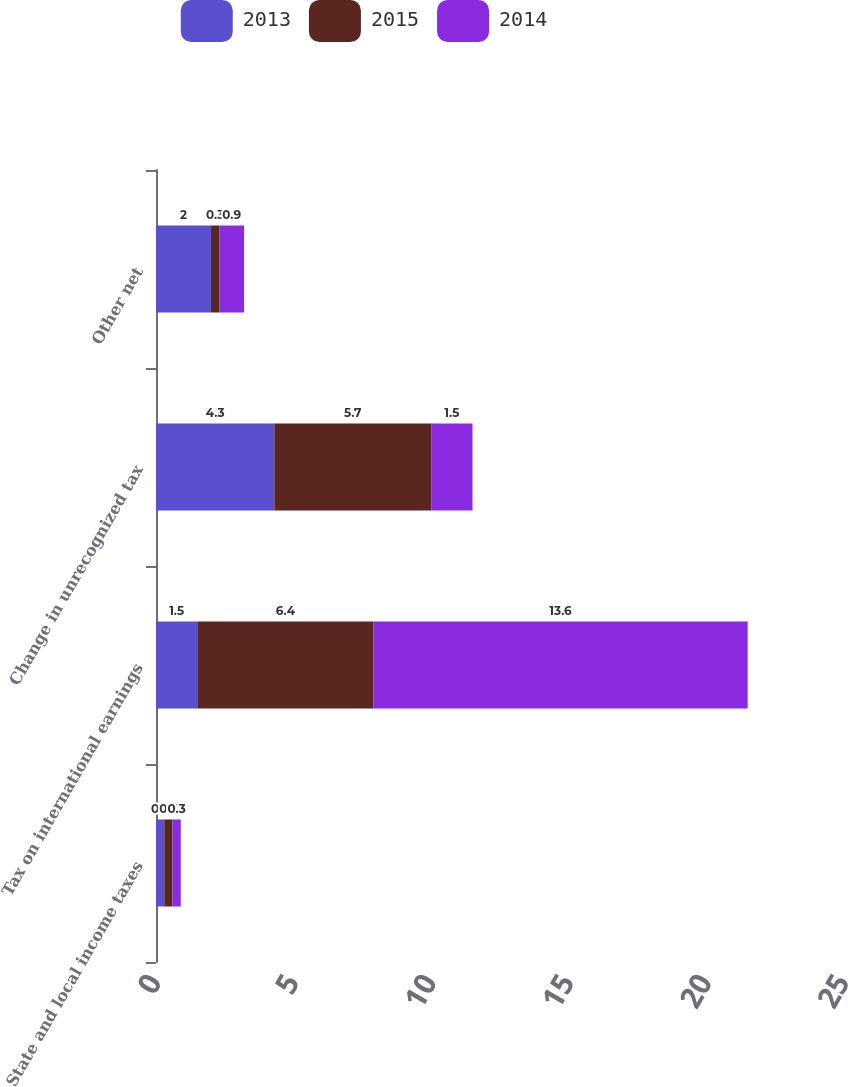Convert chart. <chart><loc_0><loc_0><loc_500><loc_500><stacked_bar_chart><ecel><fcel>State and local income taxes<fcel>Tax on international earnings<fcel>Change in unrecognized tax<fcel>Other net<nl><fcel>2013<fcel>0.3<fcel>1.5<fcel>4.3<fcel>2<nl><fcel>2015<fcel>0.3<fcel>6.4<fcel>5.7<fcel>0.3<nl><fcel>2014<fcel>0.3<fcel>13.6<fcel>1.5<fcel>0.9<nl></chart> 